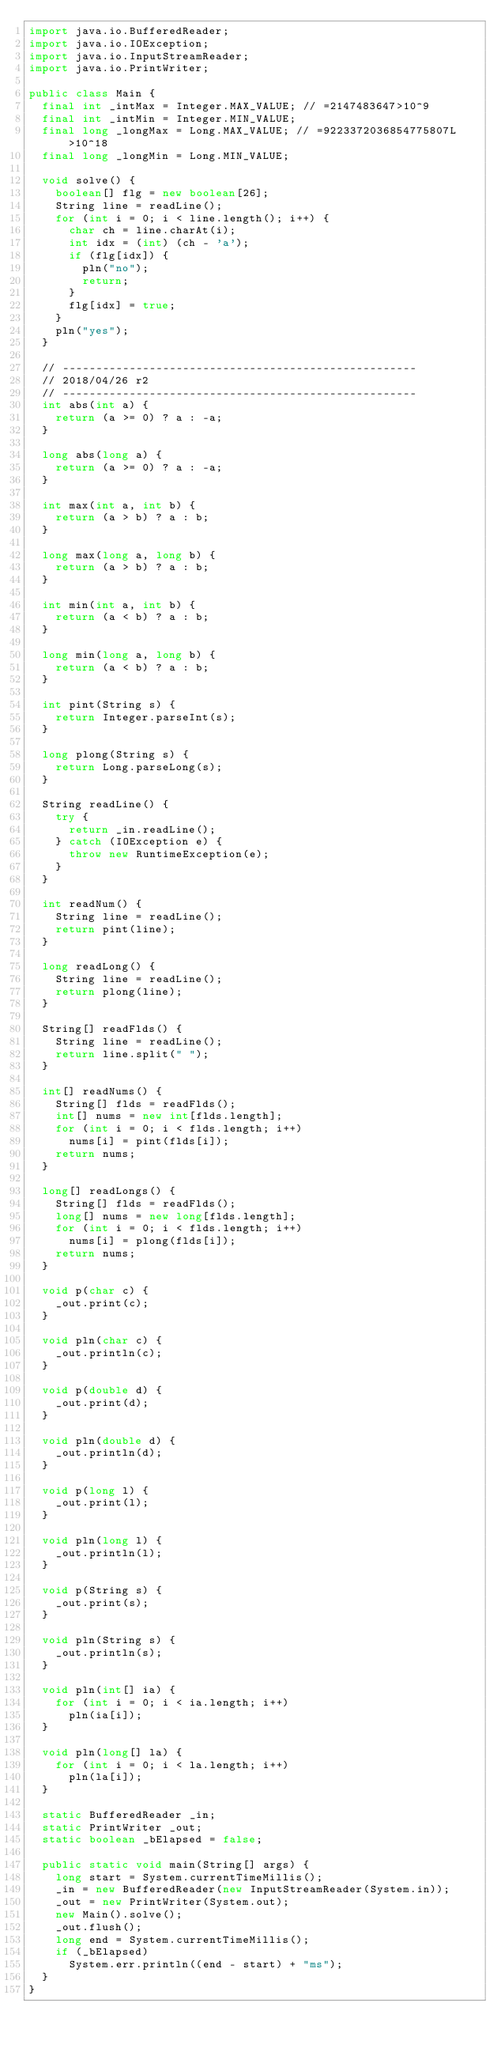Convert code to text. <code><loc_0><loc_0><loc_500><loc_500><_Java_>import java.io.BufferedReader;
import java.io.IOException;
import java.io.InputStreamReader;
import java.io.PrintWriter;

public class Main {
	final int _intMax = Integer.MAX_VALUE; // =2147483647>10^9
	final int _intMin = Integer.MIN_VALUE;
	final long _longMax = Long.MAX_VALUE; // =9223372036854775807L>10^18
	final long _longMin = Long.MIN_VALUE;

	void solve() {
		boolean[] flg = new boolean[26];
		String line = readLine();
		for (int i = 0; i < line.length(); i++) {
			char ch = line.charAt(i);
			int idx = (int) (ch - 'a');
			if (flg[idx]) {
				pln("no");
				return;
			}
			flg[idx] = true;
		}
		pln("yes");
	}

	// -----------------------------------------------------
	// 2018/04/26 r2
	// -----------------------------------------------------
	int abs(int a) {
		return (a >= 0) ? a : -a;
	}

	long abs(long a) {
		return (a >= 0) ? a : -a;
	}

	int max(int a, int b) {
		return (a > b) ? a : b;
	}

	long max(long a, long b) {
		return (a > b) ? a : b;
	}

	int min(int a, int b) {
		return (a < b) ? a : b;
	}

	long min(long a, long b) {
		return (a < b) ? a : b;
	}

	int pint(String s) {
		return Integer.parseInt(s);
	}

	long plong(String s) {
		return Long.parseLong(s);
	}

	String readLine() {
		try {
			return _in.readLine();
		} catch (IOException e) {
			throw new RuntimeException(e);
		}
	}

	int readNum() {
		String line = readLine();
		return pint(line);
	}

	long readLong() {
		String line = readLine();
		return plong(line);
	}

	String[] readFlds() {
		String line = readLine();
		return line.split(" ");
	}

	int[] readNums() {
		String[] flds = readFlds();
		int[] nums = new int[flds.length];
		for (int i = 0; i < flds.length; i++)
			nums[i] = pint(flds[i]);
		return nums;
	}

	long[] readLongs() {
		String[] flds = readFlds();
		long[] nums = new long[flds.length];
		for (int i = 0; i < flds.length; i++)
			nums[i] = plong(flds[i]);
		return nums;
	}

	void p(char c) {
		_out.print(c);
	}

	void pln(char c) {
		_out.println(c);
	}

	void p(double d) {
		_out.print(d);
	}

	void pln(double d) {
		_out.println(d);
	}

	void p(long l) {
		_out.print(l);
	}

	void pln(long l) {
		_out.println(l);
	}

	void p(String s) {
		_out.print(s);
	}

	void pln(String s) {
		_out.println(s);
	}

	void pln(int[] ia) {
		for (int i = 0; i < ia.length; i++)
			pln(ia[i]);
	}

	void pln(long[] la) {
		for (int i = 0; i < la.length; i++)
			pln(la[i]);
	}

	static BufferedReader _in;
	static PrintWriter _out;
	static boolean _bElapsed = false;

	public static void main(String[] args) {
		long start = System.currentTimeMillis();
		_in = new BufferedReader(new InputStreamReader(System.in));
		_out = new PrintWriter(System.out);
		new Main().solve();
		_out.flush();
		long end = System.currentTimeMillis();
		if (_bElapsed)
			System.err.println((end - start) + "ms");
	}
}
</code> 